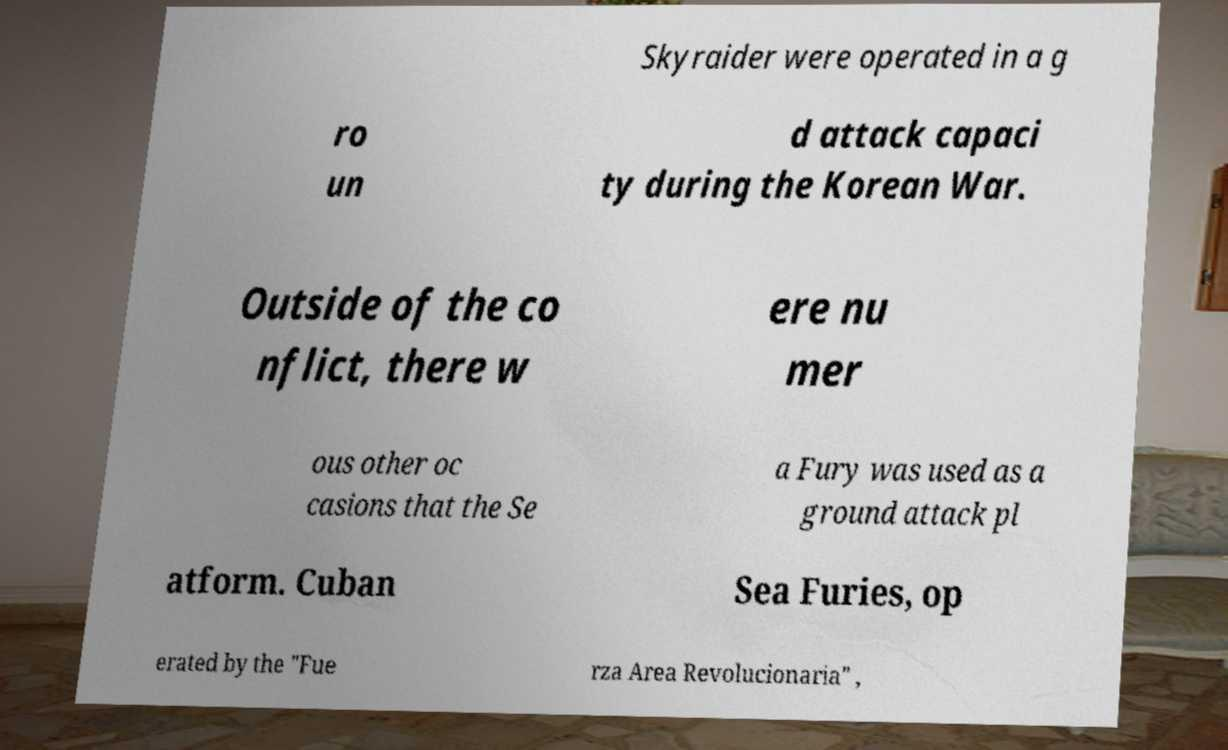Please read and relay the text visible in this image. What does it say? Skyraider were operated in a g ro un d attack capaci ty during the Korean War. Outside of the co nflict, there w ere nu mer ous other oc casions that the Se a Fury was used as a ground attack pl atform. Cuban Sea Furies, op erated by the "Fue rza Area Revolucionaria" , 